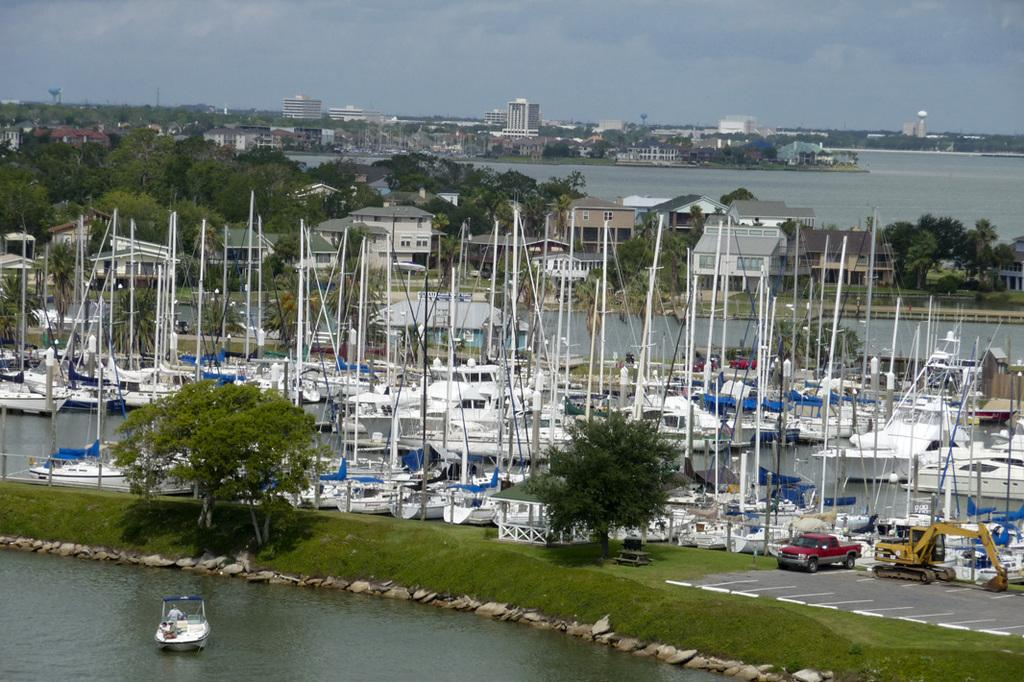What is on the water in the image? There are boats on the water in the image. What is on the road in the image? There are vehicles on the road in the image. What type of vegetation can be seen in the image? There are trees in the image. What can be seen in the background of the image? There are buildings and the sky visible in the background of the image. What type of memory is stored in the bone depicted in the image? There is no bone or memory present in the image. How is the rice being used in the image? There is no rice present in the image. 